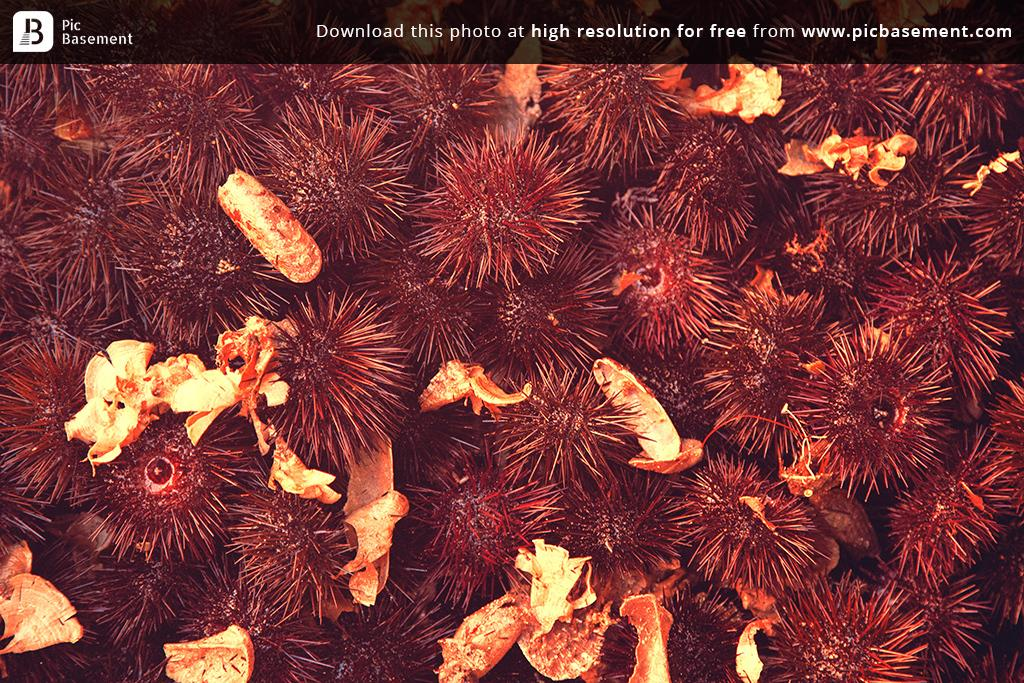What type of plants can be seen in the image? There are flowers in the image. Is there any text or symbol present at the top of the image? Yes, there is a watermark at the top of the image. What is the answer to the riddle at the top of the image? There is no riddle present in the image; it only contains a watermark. 